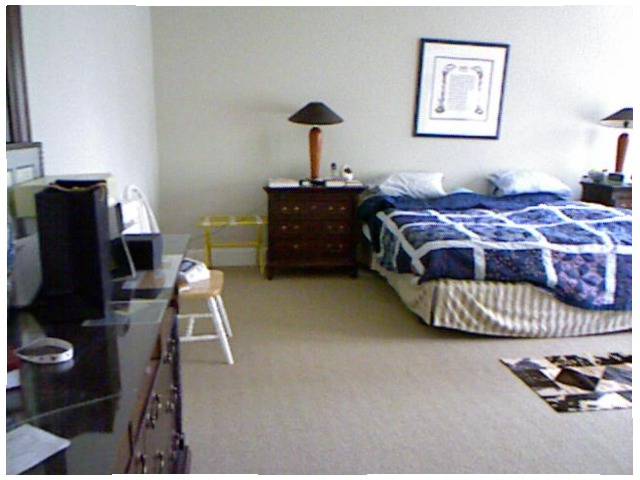<image>
Is there a chair on the floor? Yes. Looking at the image, I can see the chair is positioned on top of the floor, with the floor providing support. Is there a pillow on the bed? Yes. Looking at the image, I can see the pillow is positioned on top of the bed, with the bed providing support. Is the pillow on the bed? Yes. Looking at the image, I can see the pillow is positioned on top of the bed, with the bed providing support. Where is the pillow in relation to the pillow? Is it on the pillow? No. The pillow is not positioned on the pillow. They may be near each other, but the pillow is not supported by or resting on top of the pillow. Is there a dresser behind the chair? No. The dresser is not behind the chair. From this viewpoint, the dresser appears to be positioned elsewhere in the scene. Is the picture frame above the bed? Yes. The picture frame is positioned above the bed in the vertical space, higher up in the scene. Is there a bed to the right of the picture? No. The bed is not to the right of the picture. The horizontal positioning shows a different relationship. Is there a chair to the left of the table? No. The chair is not to the left of the table. From this viewpoint, they have a different horizontal relationship. 